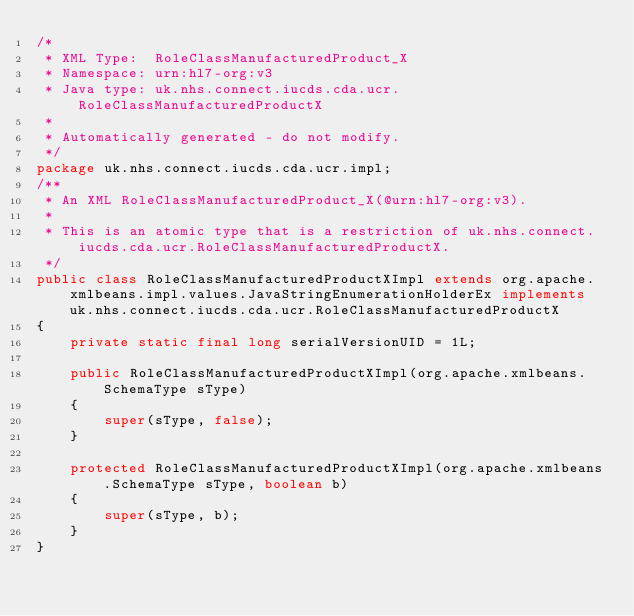Convert code to text. <code><loc_0><loc_0><loc_500><loc_500><_Java_>/*
 * XML Type:  RoleClassManufacturedProduct_X
 * Namespace: urn:hl7-org:v3
 * Java type: uk.nhs.connect.iucds.cda.ucr.RoleClassManufacturedProductX
 *
 * Automatically generated - do not modify.
 */
package uk.nhs.connect.iucds.cda.ucr.impl;
/**
 * An XML RoleClassManufacturedProduct_X(@urn:hl7-org:v3).
 *
 * This is an atomic type that is a restriction of uk.nhs.connect.iucds.cda.ucr.RoleClassManufacturedProductX.
 */
public class RoleClassManufacturedProductXImpl extends org.apache.xmlbeans.impl.values.JavaStringEnumerationHolderEx implements uk.nhs.connect.iucds.cda.ucr.RoleClassManufacturedProductX
{
    private static final long serialVersionUID = 1L;
    
    public RoleClassManufacturedProductXImpl(org.apache.xmlbeans.SchemaType sType)
    {
        super(sType, false);
    }
    
    protected RoleClassManufacturedProductXImpl(org.apache.xmlbeans.SchemaType sType, boolean b)
    {
        super(sType, b);
    }
}
</code> 